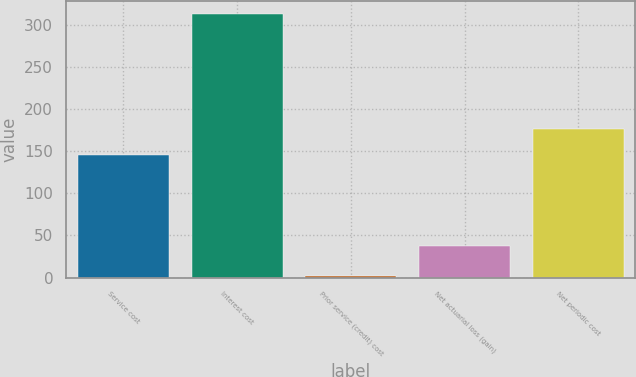Convert chart. <chart><loc_0><loc_0><loc_500><loc_500><bar_chart><fcel>Service cost<fcel>Interest cost<fcel>Prior service (credit) cost<fcel>Net actuarial loss (gain)<fcel>Net periodic cost<nl><fcel>145<fcel>313<fcel>2<fcel>37<fcel>176.1<nl></chart> 